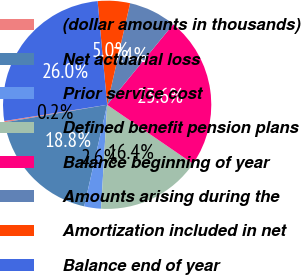Convert chart to OTSL. <chart><loc_0><loc_0><loc_500><loc_500><pie_chart><fcel>(dollar amounts in thousands)<fcel>Net actuarial loss<fcel>Prior service cost<fcel>Defined benefit pension plans<fcel>Balance beginning of year<fcel>Amounts arising during the<fcel>Amortization included in net<fcel>Balance end of year<nl><fcel>0.21%<fcel>18.76%<fcel>2.61%<fcel>16.36%<fcel>23.64%<fcel>7.4%<fcel>5.0%<fcel>26.03%<nl></chart> 